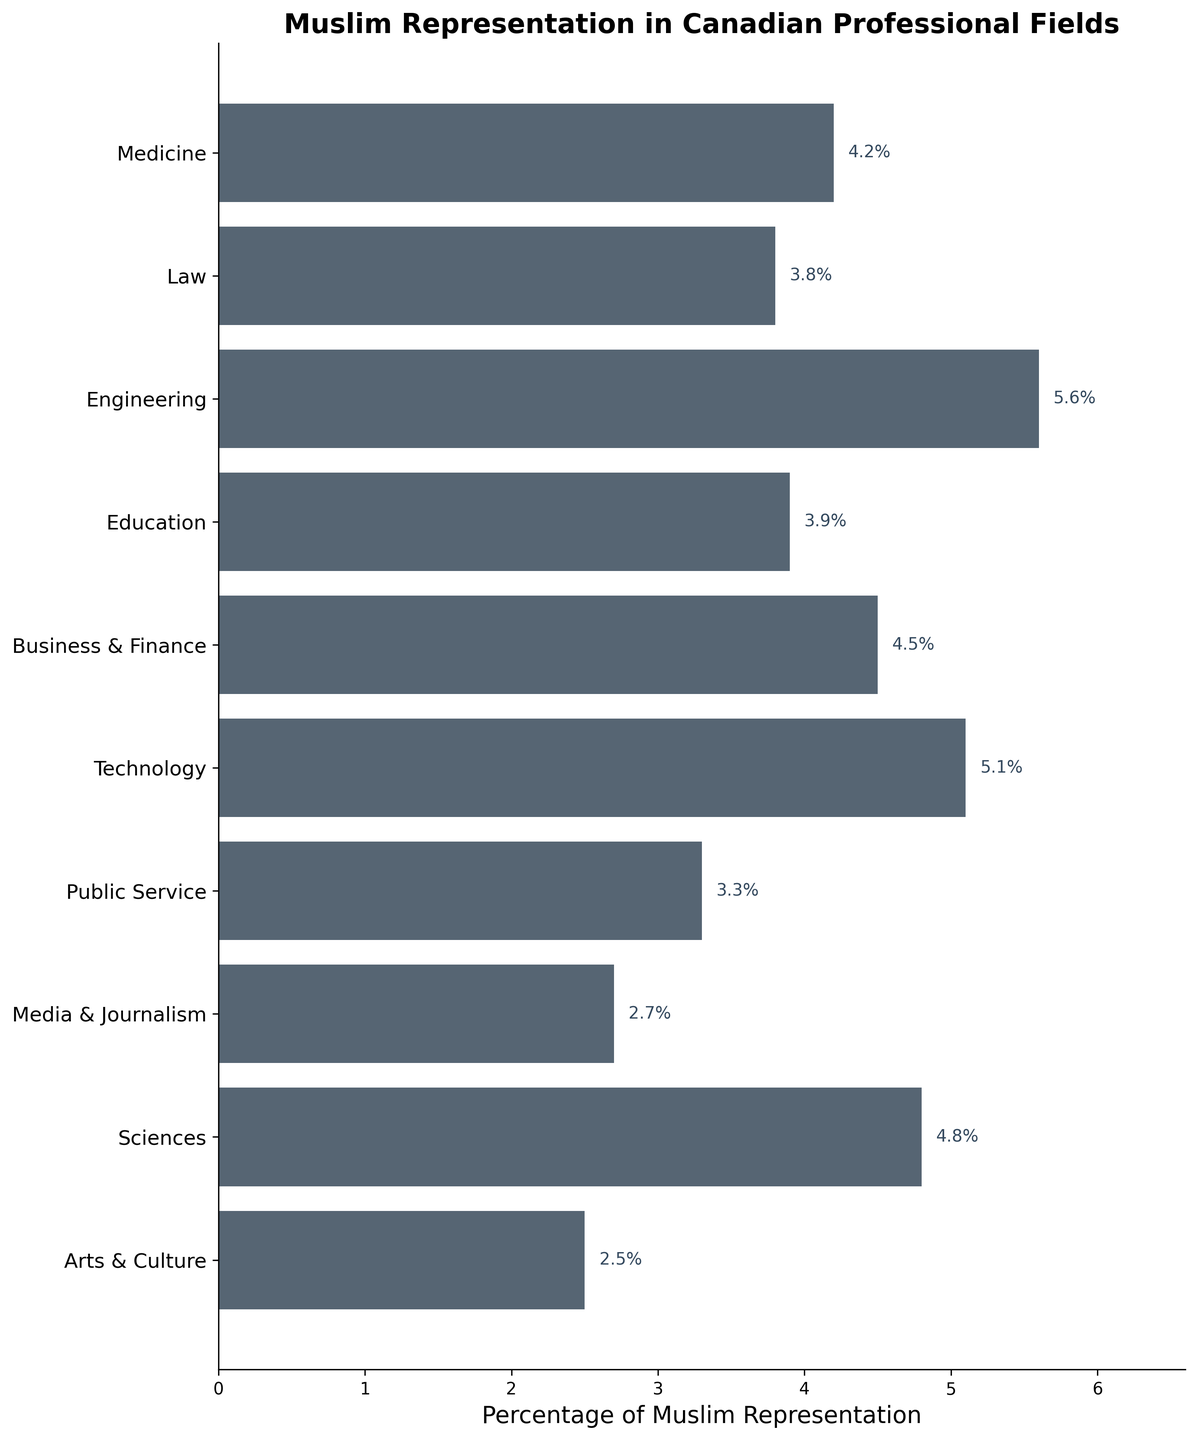What is the title of the figure? The title of the figure is displayed at the top and gives an overview of the data being represented. It reads "Muslim Representation in Canadian Professional Fields."
Answer: Muslim Representation in Canadian Professional Fields Which professional field has the highest percentage of Muslim representation? By looking at the bars and their labels, the field with the longest bar indicates the highest percentage. Engineering has the highest percentage of Muslim representation at 5.6%.
Answer: Engineering Which professional field has the lowest percentage of Muslim representation? The shortest bar indicates the lowest percentage. Arts & Culture has the lowest percentage at 2.5%.
Answer: Arts & Culture What is the percentage of Muslim representation in Public Service? Locate the bar labeled "Public Service" and read the value at the end of the bar. The percentage is 3.3%.
Answer: 3.3% Are there any fields with Muslim representation between 4% and 5%? Look for bars with values within the range of 4% to 5%. Medicine (4.2%), Business & Finance (4.5%), and Sciences (4.8%) fall within this range.
Answer: Medicine, Business & Finance, Sciences What is the total percentage of Muslim representation in Law and Education combined? Add the percentages for Law and Education. Law has 3.8% and Education has 3.9%. The total is 3.8% + 3.9% = 7.7%.
Answer: 7.7% Compare the Muslim representation in Technology and Media & Journalism. Which is greater and by how much? Technology has a representation of 5.1% while Media & Journalism has 2.7%. The difference is 5.1% - 2.7% = 2.4%. Technology has 2.4% more representation than Media & Journalism.
Answer: Technology by 2.4% Calculate the average percentage of Muslim representation across all the professional fields. Sum all the percentages and divide by the number of fields (10). (4.2 + 3.8 + 5.6 + 3.9 + 4.5 + 5.1 + 3.3 + 2.7 + 4.8 + 2.5) / 10 = 40.4 / 10 = 4.04%. The average representation is 4.04%.
Answer: 4.04% How many professional fields have Muslim representation above the average percentage? First, find the number of fields with percentages greater than 4.04%. These fields are Engineering (5.6%), Technology (5.1%), Business & Finance (4.5%), and Sciences (4.8%). There are 4 fields above the average.
Answer: 4 What is the difference in Muslim representation between Medicine and Sciences? Subtract the percentage for Medicine from the percentage for Sciences. Sciences has 4.8% and Medicine has 4.2%, so 4.8% - 4.2% = 0.6%. The difference is 0.6%.
Answer: 0.6% 